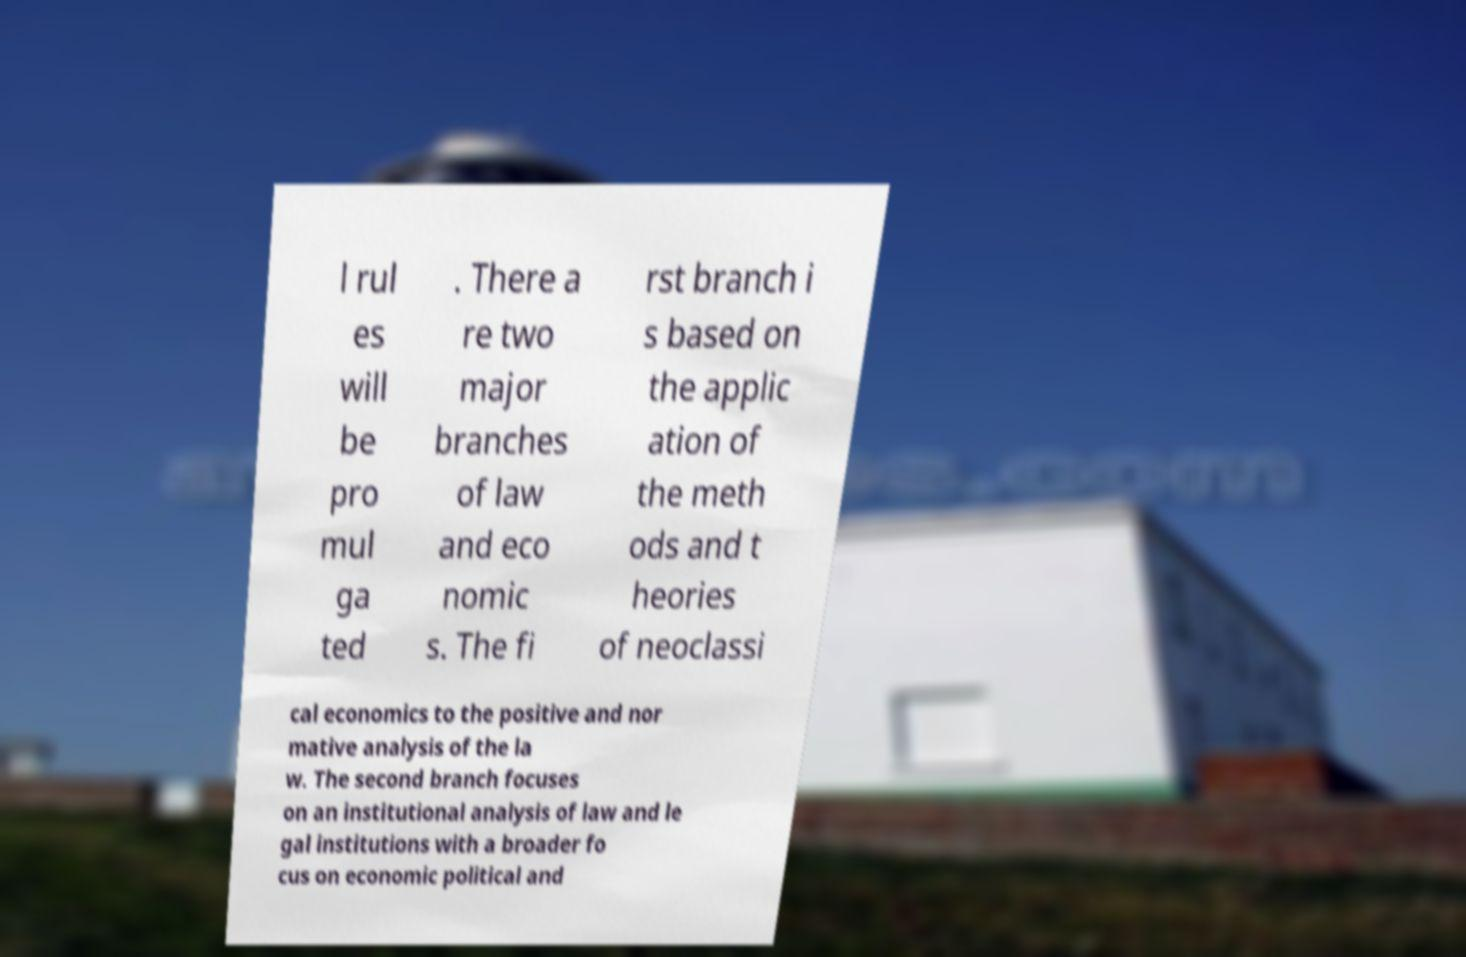Can you accurately transcribe the text from the provided image for me? l rul es will be pro mul ga ted . There a re two major branches of law and eco nomic s. The fi rst branch i s based on the applic ation of the meth ods and t heories of neoclassi cal economics to the positive and nor mative analysis of the la w. The second branch focuses on an institutional analysis of law and le gal institutions with a broader fo cus on economic political and 